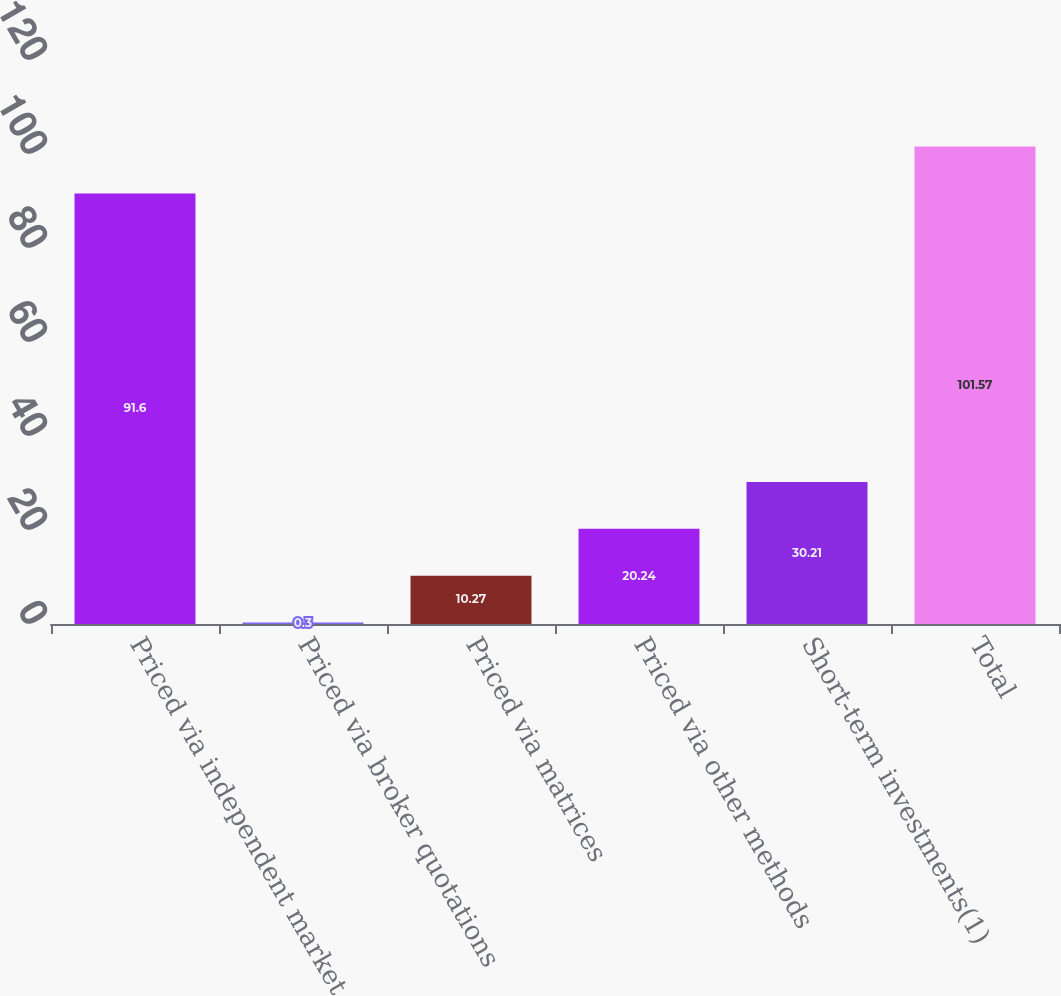<chart> <loc_0><loc_0><loc_500><loc_500><bar_chart><fcel>Priced via independent market<fcel>Priced via broker quotations<fcel>Priced via matrices<fcel>Priced via other methods<fcel>Short-term investments(1)<fcel>Total<nl><fcel>91.6<fcel>0.3<fcel>10.27<fcel>20.24<fcel>30.21<fcel>101.57<nl></chart> 